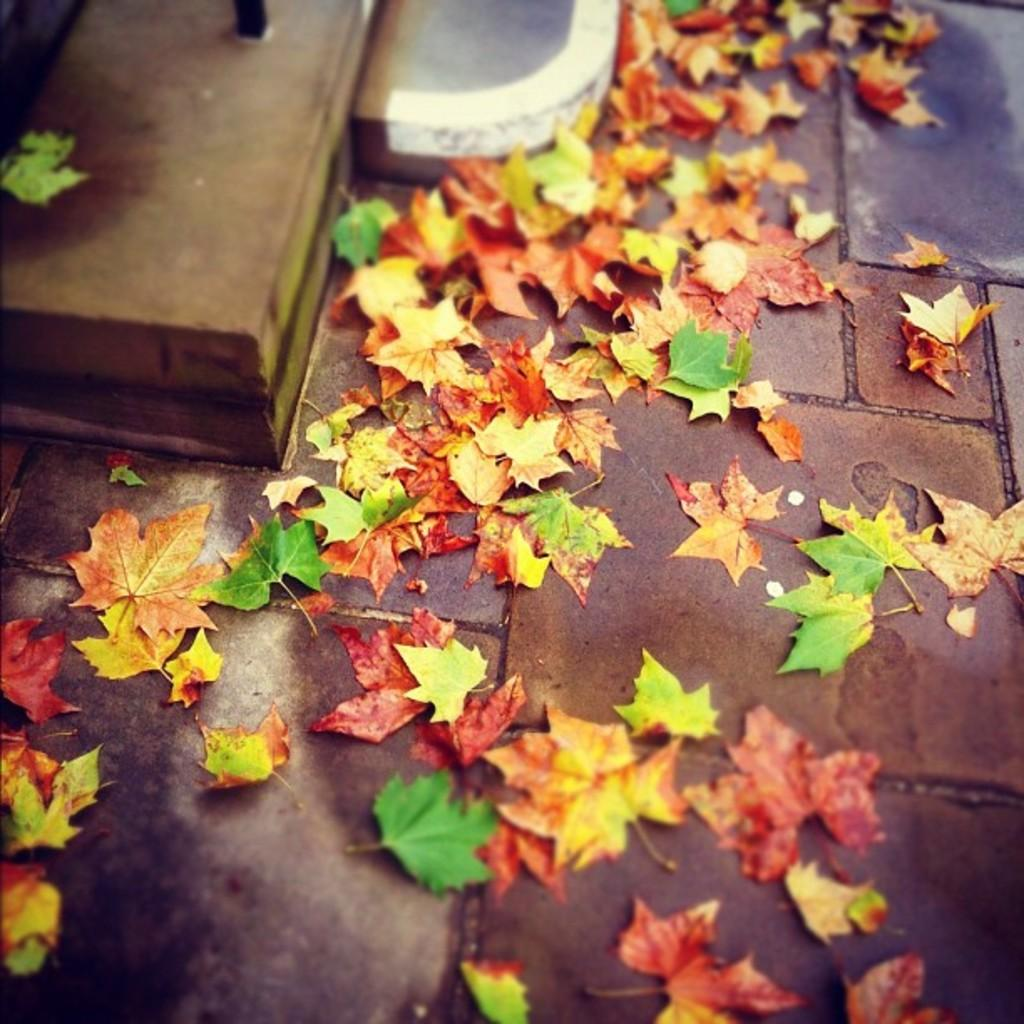What type of vegetation is present in the image? The image contains dry leaves and leaves. What architectural feature can be seen at the top of the image? There is a staircase at the top of the image. What type of surface is visible at the bottom of the image? There is a pavement at the bottom of the image. Can you describe the snake that is slithering on the pavement in the image? There is no snake present in the image; it only contains dry leaves, leaves, a staircase, and a pavement. 